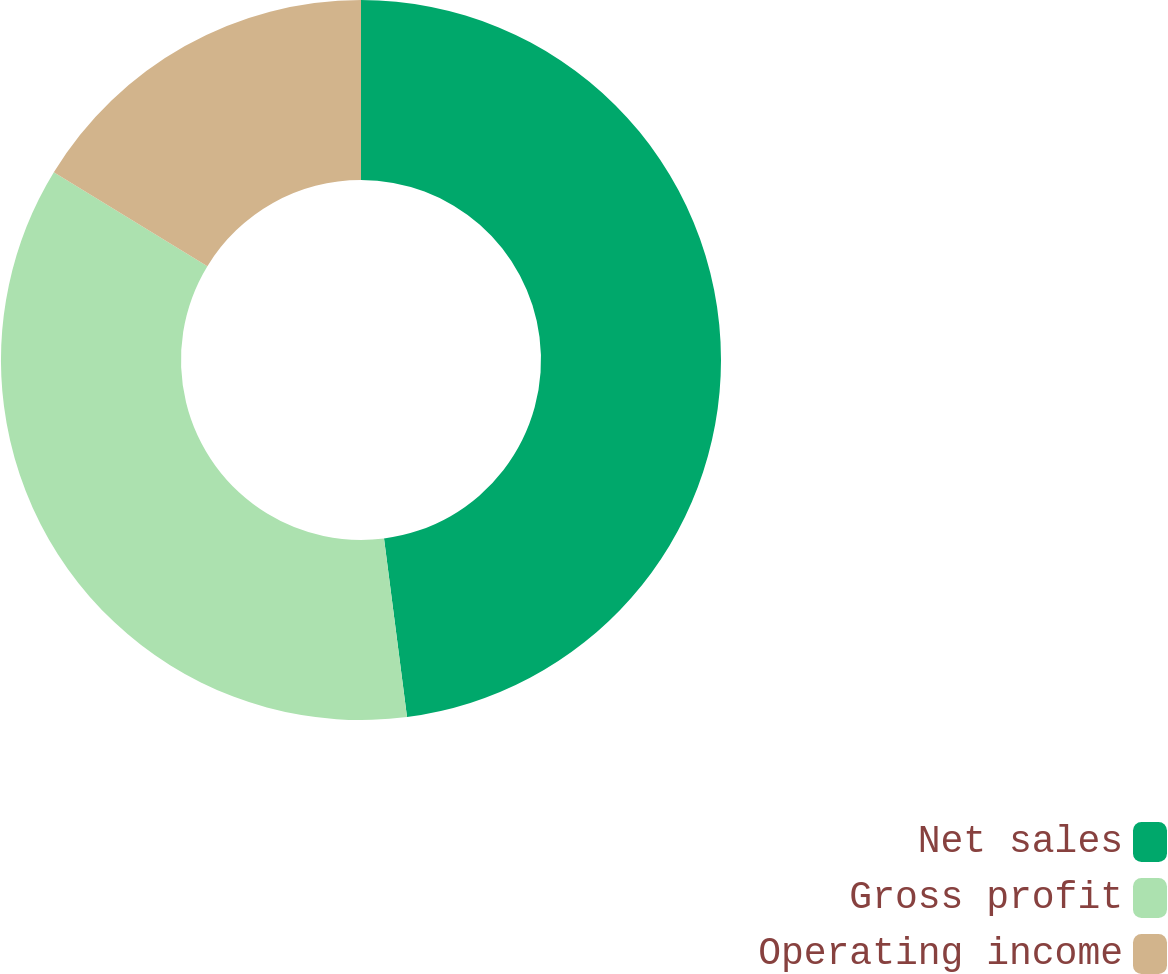Convert chart to OTSL. <chart><loc_0><loc_0><loc_500><loc_500><pie_chart><fcel>Net sales<fcel>Gross profit<fcel>Operating income<nl><fcel>47.96%<fcel>35.77%<fcel>16.27%<nl></chart> 